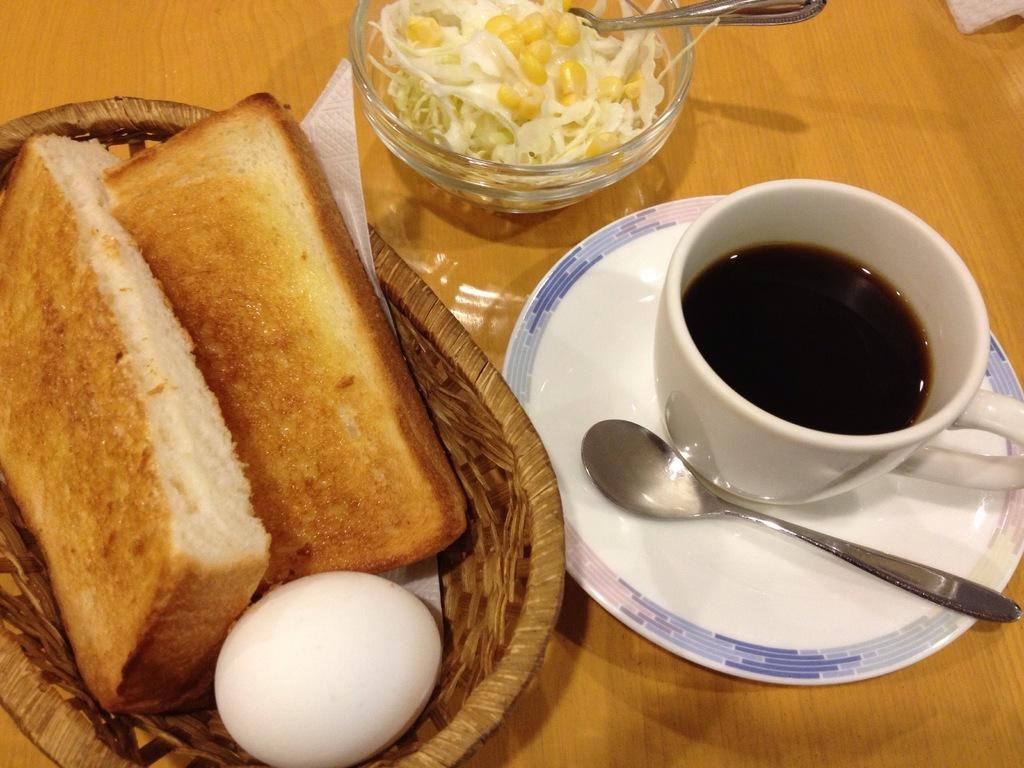How would you summarize this image in a sentence or two? In this image we can see a cup and some liquid in it, here is the plate on the table, here is the spoon, here is the food item in the bowl, here is the bread, egg, in the basket. 